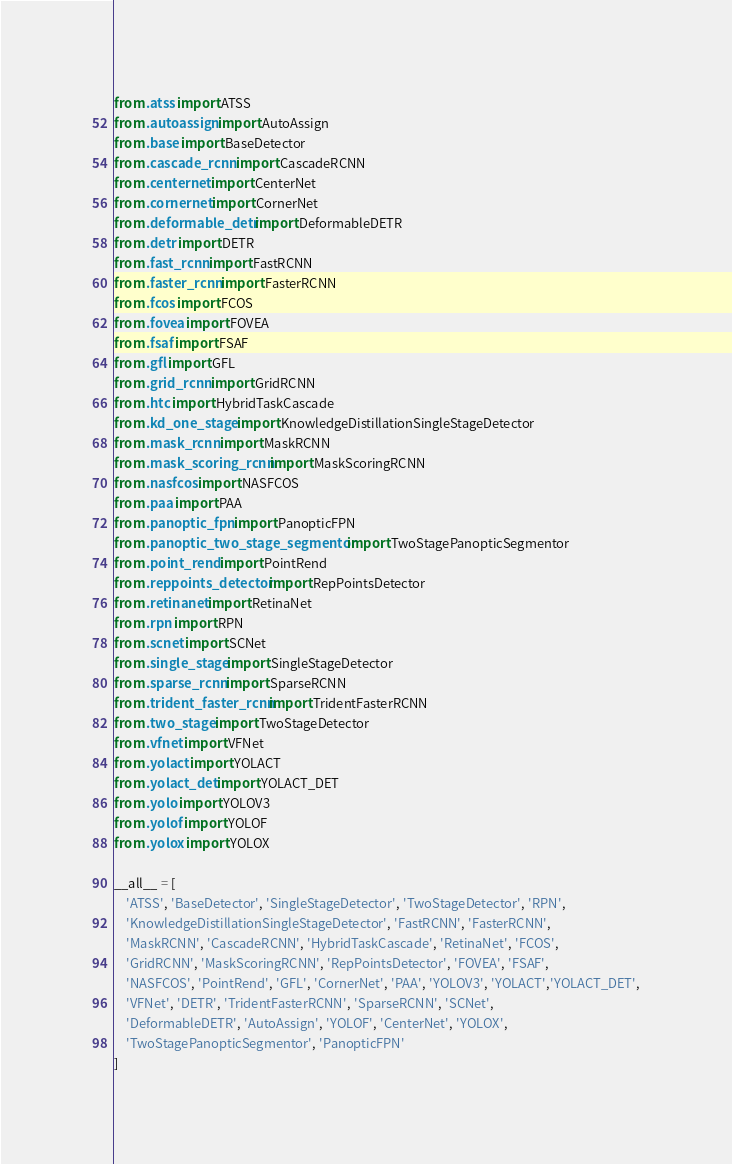<code> <loc_0><loc_0><loc_500><loc_500><_Python_>from .atss import ATSS
from .autoassign import AutoAssign
from .base import BaseDetector
from .cascade_rcnn import CascadeRCNN
from .centernet import CenterNet
from .cornernet import CornerNet
from .deformable_detr import DeformableDETR
from .detr import DETR
from .fast_rcnn import FastRCNN
from .faster_rcnn import FasterRCNN
from .fcos import FCOS
from .fovea import FOVEA
from .fsaf import FSAF
from .gfl import GFL
from .grid_rcnn import GridRCNN
from .htc import HybridTaskCascade
from .kd_one_stage import KnowledgeDistillationSingleStageDetector
from .mask_rcnn import MaskRCNN
from .mask_scoring_rcnn import MaskScoringRCNN
from .nasfcos import NASFCOS
from .paa import PAA
from .panoptic_fpn import PanopticFPN
from .panoptic_two_stage_segmentor import TwoStagePanopticSegmentor
from .point_rend import PointRend
from .reppoints_detector import RepPointsDetector
from .retinanet import RetinaNet
from .rpn import RPN
from .scnet import SCNet
from .single_stage import SingleStageDetector
from .sparse_rcnn import SparseRCNN
from .trident_faster_rcnn import TridentFasterRCNN
from .two_stage import TwoStageDetector
from .vfnet import VFNet
from .yolact import YOLACT
from .yolact_det import YOLACT_DET
from .yolo import YOLOV3
from .yolof import YOLOF
from .yolox import YOLOX

__all__ = [
    'ATSS', 'BaseDetector', 'SingleStageDetector', 'TwoStageDetector', 'RPN',
    'KnowledgeDistillationSingleStageDetector', 'FastRCNN', 'FasterRCNN',
    'MaskRCNN', 'CascadeRCNN', 'HybridTaskCascade', 'RetinaNet', 'FCOS',
    'GridRCNN', 'MaskScoringRCNN', 'RepPointsDetector', 'FOVEA', 'FSAF',
    'NASFCOS', 'PointRend', 'GFL', 'CornerNet', 'PAA', 'YOLOV3', 'YOLACT','YOLACT_DET',
    'VFNet', 'DETR', 'TridentFasterRCNN', 'SparseRCNN', 'SCNet',
    'DeformableDETR', 'AutoAssign', 'YOLOF', 'CenterNet', 'YOLOX',
    'TwoStagePanopticSegmentor', 'PanopticFPN'
]
</code> 